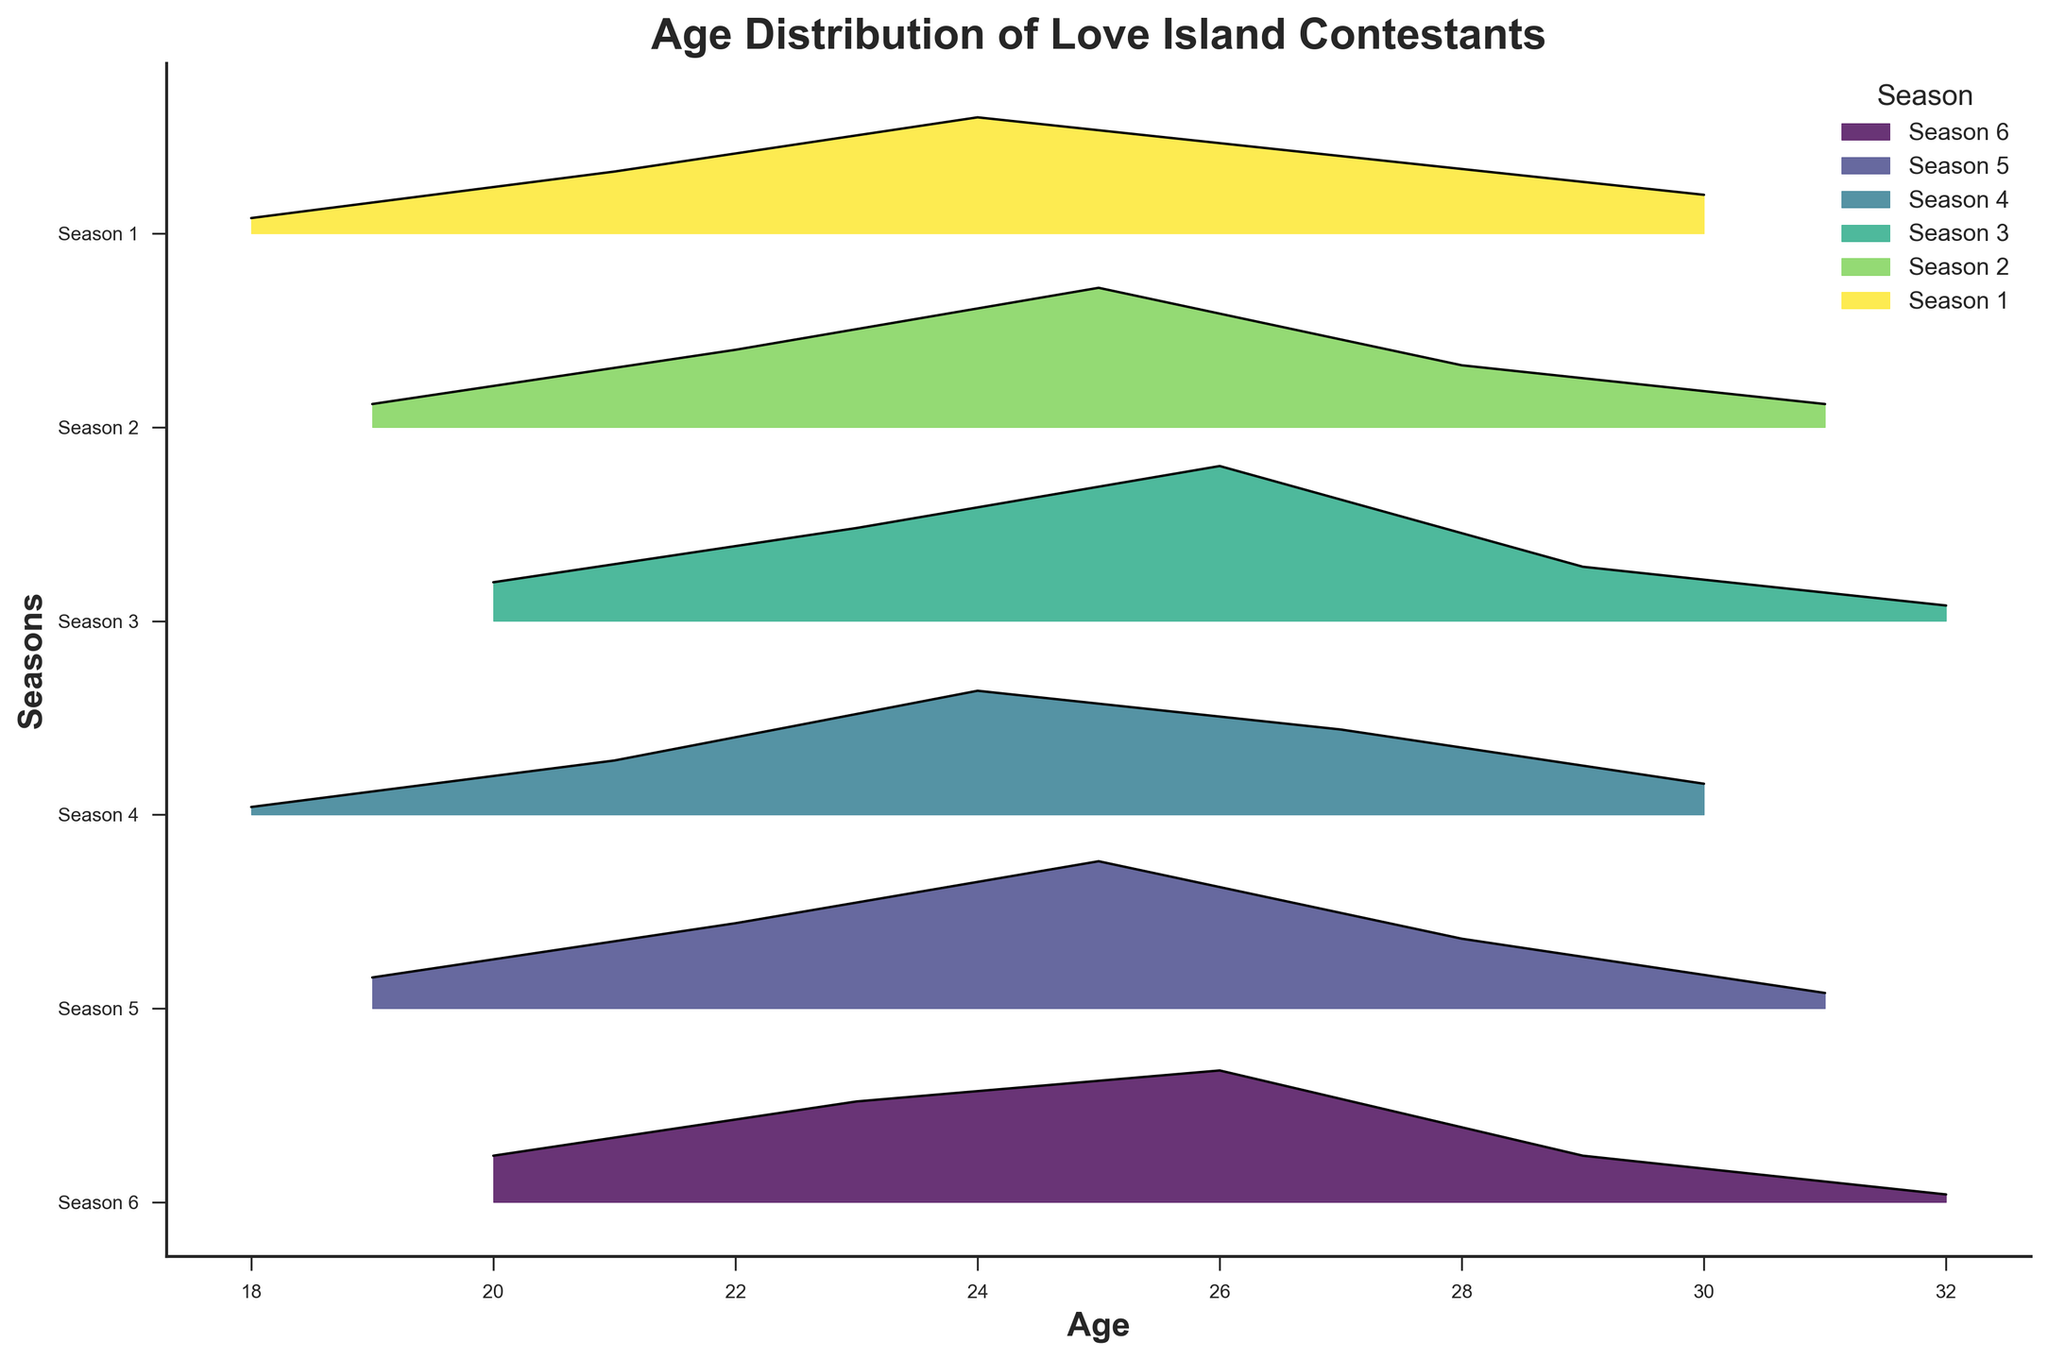How many age ticks are shown on the x-axis? The x-axis shows the distribution of ages and has ticks at 18, 19, 20, 21, 22, 23, 24, 25, 26, 27, 28, 29, 30, 31, and 32
Answer: 15 Which age range has the highest density for Season 3? By looking at the fill plot and the black line for Season 3, the highest density appears around age 26
Answer: 26 Compare the age distributions of Season 2 and Season 5. Which one has a higher density at age 25? By comparing the fill heights at age 25, Season 5 has a higher density compared to Season 2
Answer: Season 5 What is the title of the plot? The title of the plot is mentioned at the top of the figure which reads "Age Distribution of Love Island Contestants"
Answer: Age Distribution of Love Island Contestants During which season does the age of 24 have the highest density? Looking at the plots for the different seasons, Season 4 has the highest density at age 24
Answer: Season 4 Which season shows contestants with the oldest age? The oldest age shown on the plot is 32, which is present in Season 3 and Season 6
Answer: Season 3 and Season 6 How many seasons have their highest density at age 24? By inspecting the peaks in the plots, Seasons 1, 4, and 5 have their highest densities at age 24
Answer: 3 Which season has the lowest density at age 18? Season 4 has the lowest density at age 18, represented by the smallest filled area at that age
Answer: Season 4 Is there any season with a peak density exactly at age 31? None of the seasons have a peak density at age 31; the peaks occur at other ages
Answer: No 